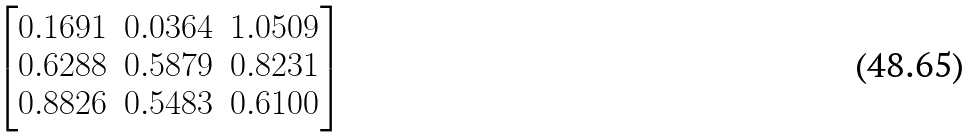Convert formula to latex. <formula><loc_0><loc_0><loc_500><loc_500>\begin{bmatrix} 0 . 1 6 9 1 & 0 . 0 3 6 4 & 1 . 0 5 0 9 \\ 0 . 6 2 8 8 & 0 . 5 8 7 9 & 0 . 8 2 3 1 \\ 0 . 8 8 2 6 & 0 . 5 4 8 3 & 0 . 6 1 0 0 \\ \end{bmatrix}</formula> 